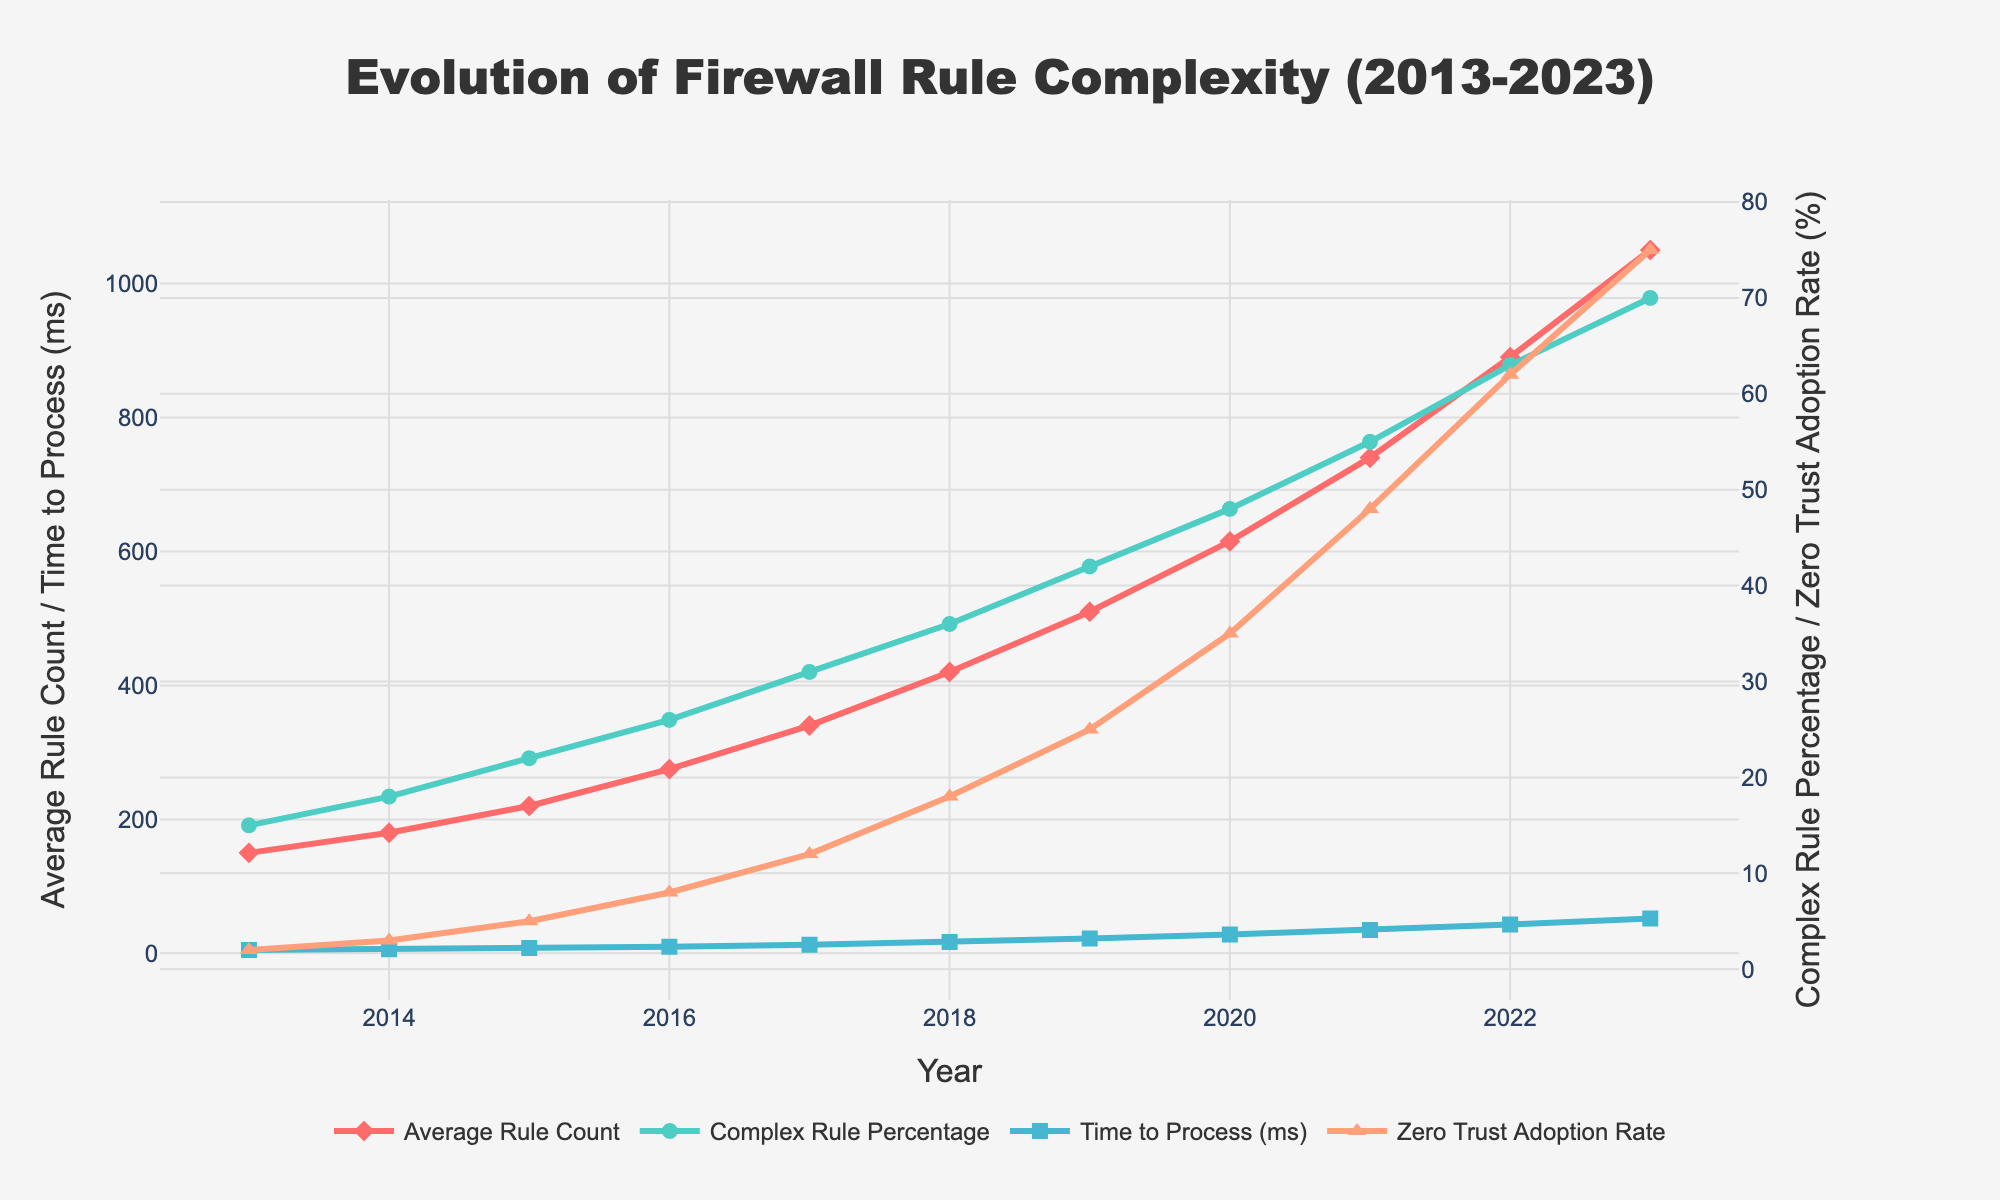What's the trend of Average Rule Count from 2013 to 2023? Observing the line representing 'Average Rule Count', it consistently increases year by year from 2013 at 150 to 2023 at 1050.
Answer: Increasing By how many milliseconds did the Time to Process increase from 2013 to 2023? Looking at the time to process (ms), it is 5 ms in 2013 and increases to 52 ms in 2023. The increase is calculated as 52 - 5 = 47 milliseconds.
Answer: 47 ms How did the Complex Rule Percentage change between 2018 and 2020? The complex rule percentage in 2018 was 36%, and in 2020 it was 48%. The change is calculated as 48% - 36% = 12%.
Answer: 12% In which year did the Zero Trust Adoption Rate show the highest increase compared to the previous year? By observing the rate's yearly increments, the steepest increase is between 2021 (48%) and 2022 (62%), resulting in a 14% increase.
Answer: 2022 Comparing 2016 and 2021, which year had a higher Time to Process and by how much? In 2016, the time to process was 10 ms, and in 2021, it was 35 ms. The difference is calculated as 35 ms - 10 ms = 25 ms.
Answer: 2021, 25 ms What is the combined value of Average Rule Count and Time to Process in 2019? In 2019, the Average Rule Count is 510 and Time to Process is 22 ms. The combined value is 510 + 22 = 532.
Answer: 532 What visual pattern can be observed about Zero Trust Adoption Rate in recent years? The Zero Trust Adoption Rate graph shows an accelerating upward trend, especially notable from 2020 to 2023.
Answer: Accelerating upward trend When did the Complex Rule Percentage reach 50% or more for the first time? The Complex Rule Percentage reaches 55% in 2021, which is the first time it surpasses 50%.
Answer: 2021 Is the rate of increase in Average Rule Count visually steeper before or after 2018? The slope of the line representing Average Rule Count becomes steeper after 2018, indicating a faster increase rate.
Answer: After 2018 How does the Complex Rule Percentage in 2016 compare to the Zero Trust Adoption Rate in the same year? In 2016, the Complex Rule Percentage is 26%, while the Zero Trust Adoption Rate is 8%. Thus, the Complex Rule Percentage is higher by 18%.
Answer: Complex Rule Percentage is higher by 18% 